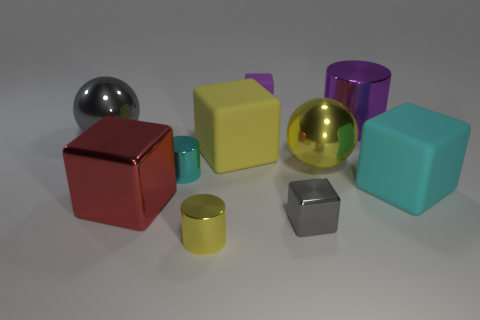Subtract all yellow blocks. How many blocks are left? 4 Subtract all purple rubber cubes. How many cubes are left? 4 Subtract 1 blocks. How many blocks are left? 4 Subtract all green blocks. Subtract all green spheres. How many blocks are left? 5 Subtract all cylinders. How many objects are left? 7 Subtract all gray blocks. Subtract all spheres. How many objects are left? 7 Add 5 purple cylinders. How many purple cylinders are left? 6 Add 5 yellow things. How many yellow things exist? 8 Subtract 0 cyan balls. How many objects are left? 10 